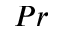Convert formula to latex. <formula><loc_0><loc_0><loc_500><loc_500>P r</formula> 